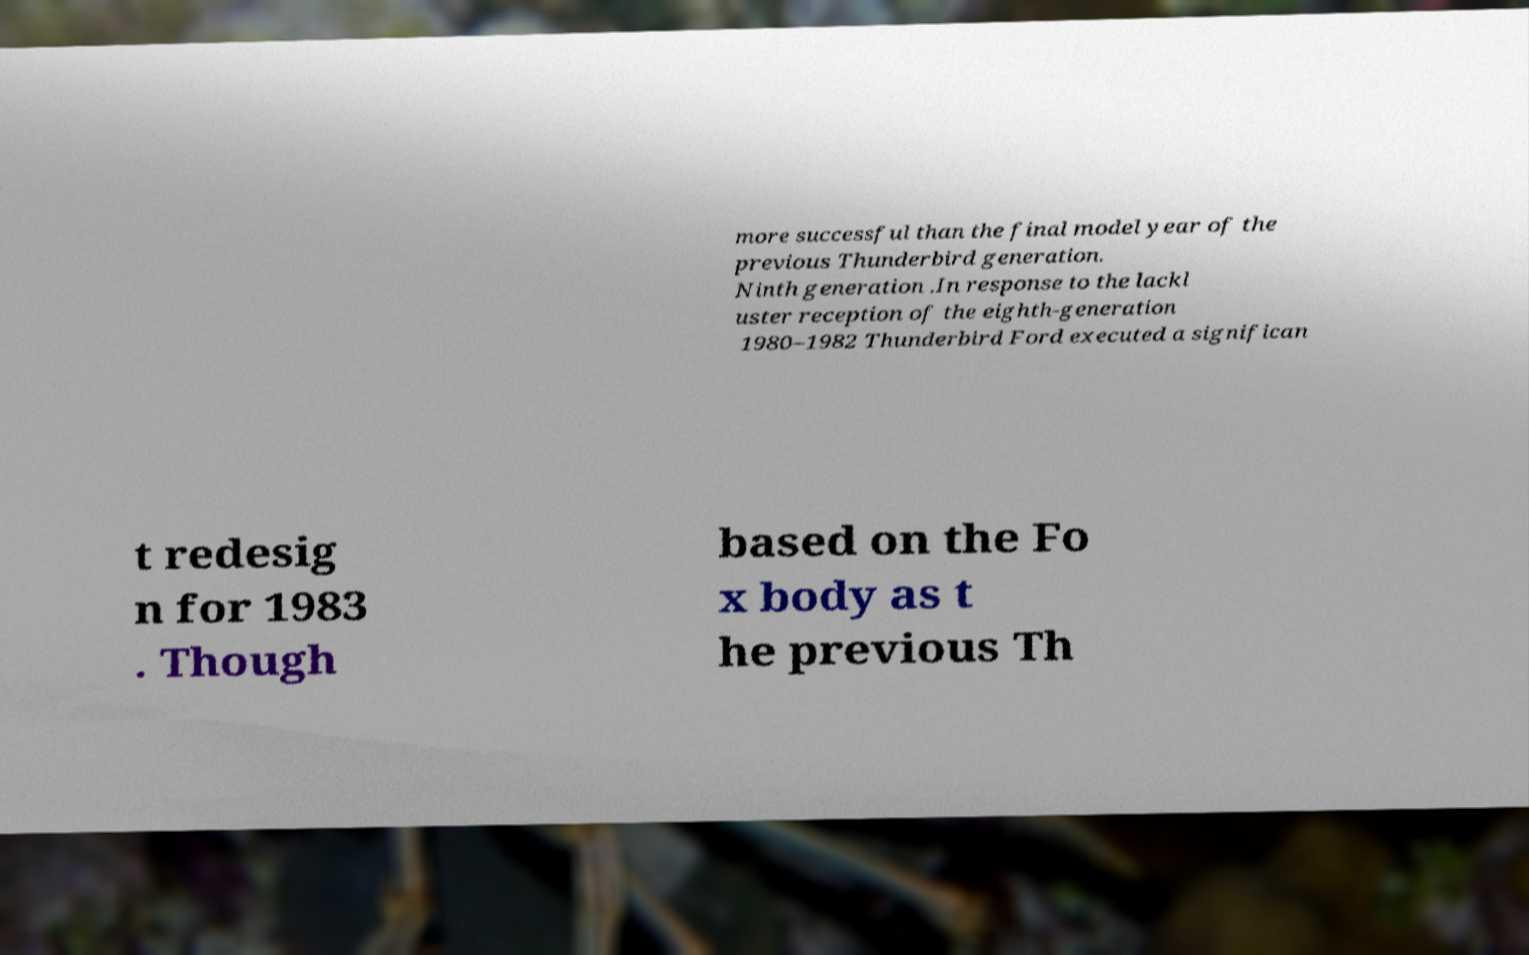Can you read and provide the text displayed in the image?This photo seems to have some interesting text. Can you extract and type it out for me? more successful than the final model year of the previous Thunderbird generation. Ninth generation .In response to the lackl uster reception of the eighth-generation 1980–1982 Thunderbird Ford executed a significan t redesig n for 1983 . Though based on the Fo x body as t he previous Th 